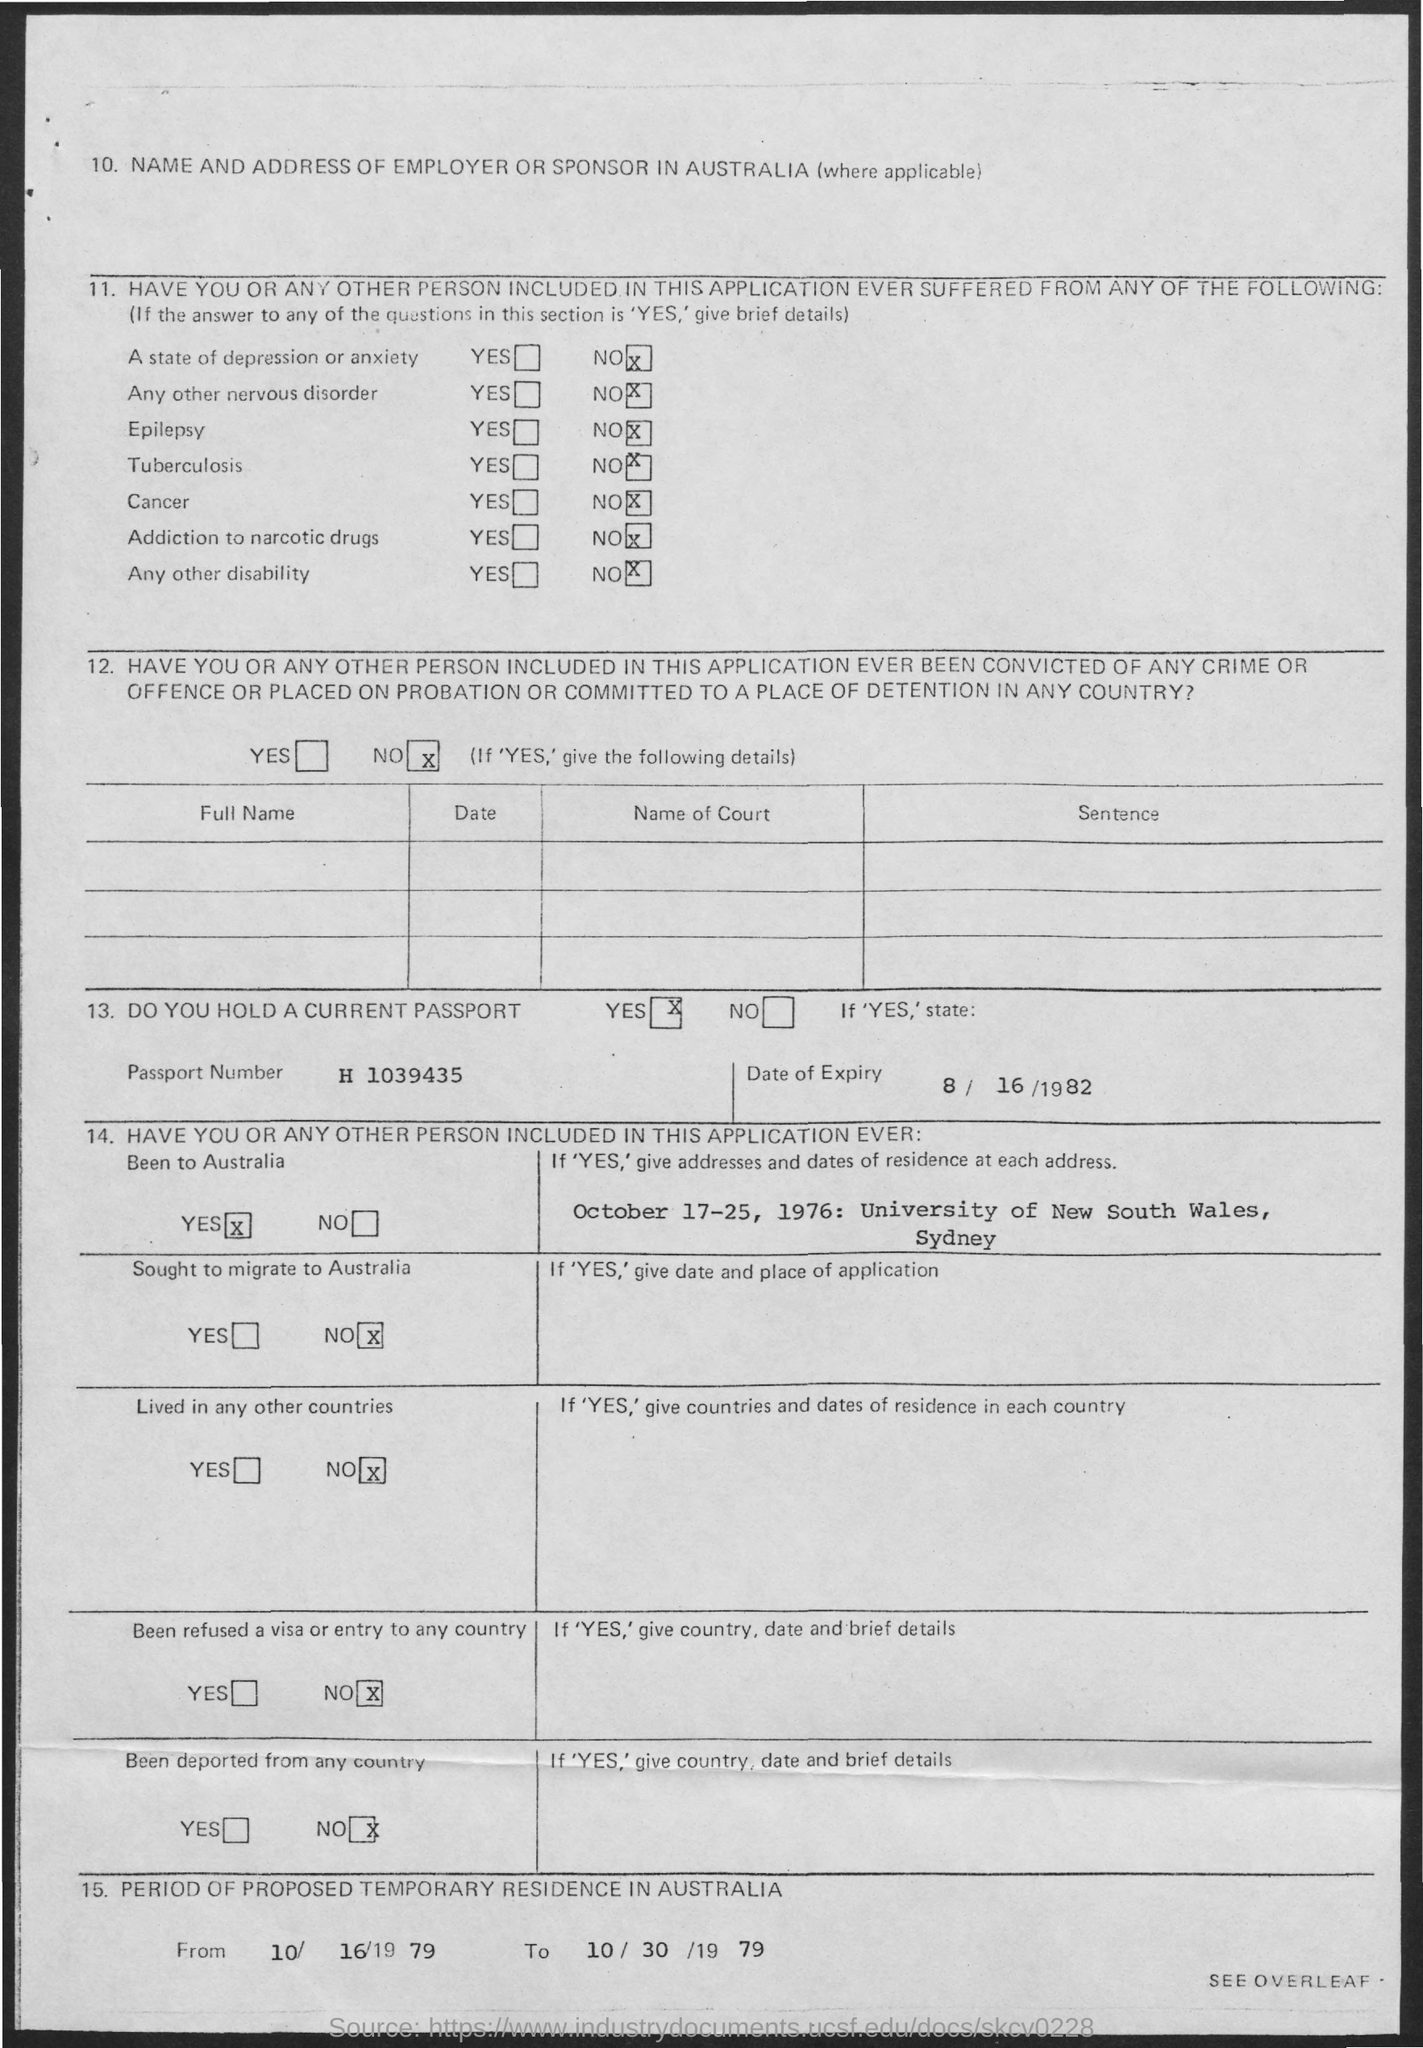What is the address?
Offer a very short reply. University of New South Wales, Sydney. 